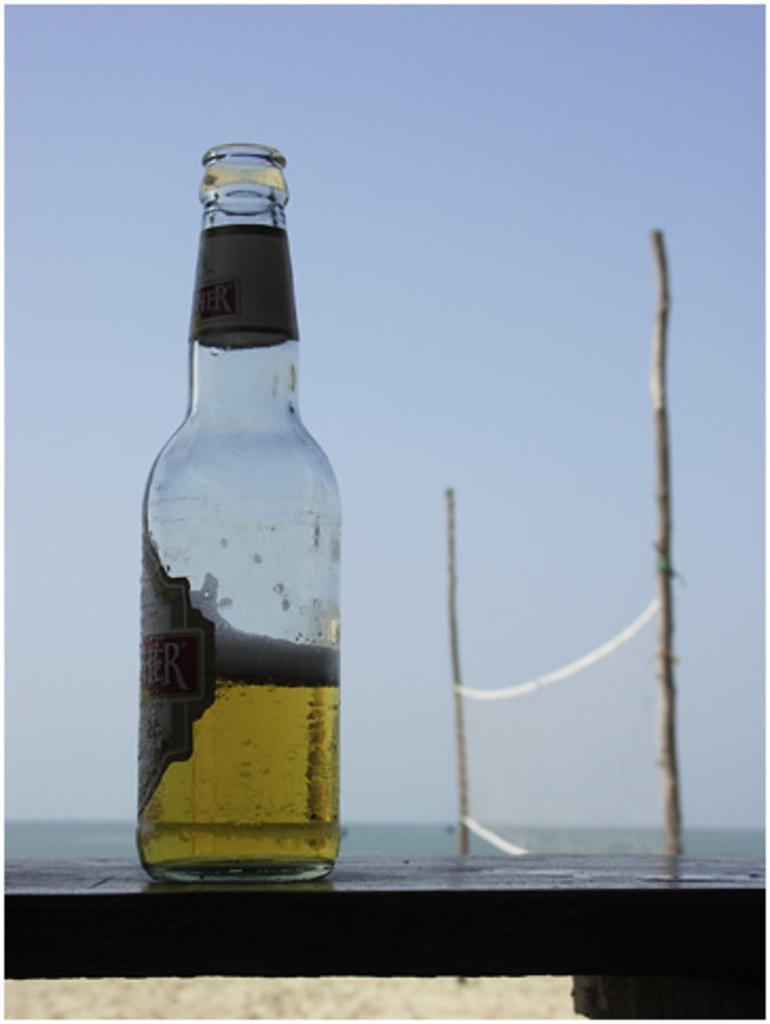Please provide a concise description of this image. This picture shows a bottle placed on the table. In the background there is a net and a sky. 